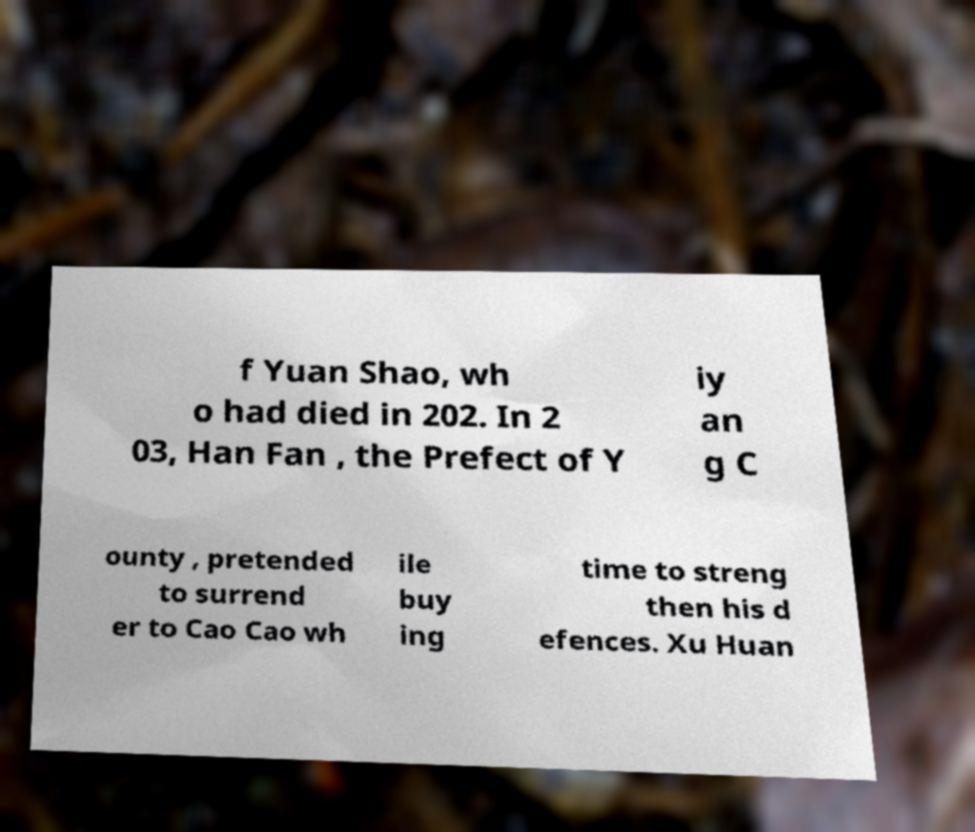I need the written content from this picture converted into text. Can you do that? f Yuan Shao, wh o had died in 202. In 2 03, Han Fan , the Prefect of Y iy an g C ounty , pretended to surrend er to Cao Cao wh ile buy ing time to streng then his d efences. Xu Huan 